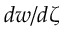<formula> <loc_0><loc_0><loc_500><loc_500>d w / d \zeta</formula> 